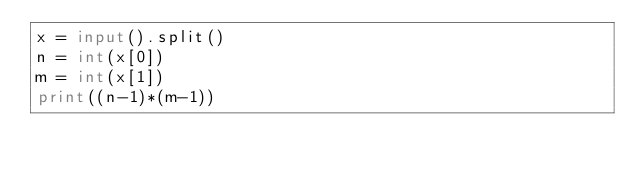Convert code to text. <code><loc_0><loc_0><loc_500><loc_500><_Python_>x = input().split()
n = int(x[0])
m = int(x[1])
print((n-1)*(m-1))</code> 